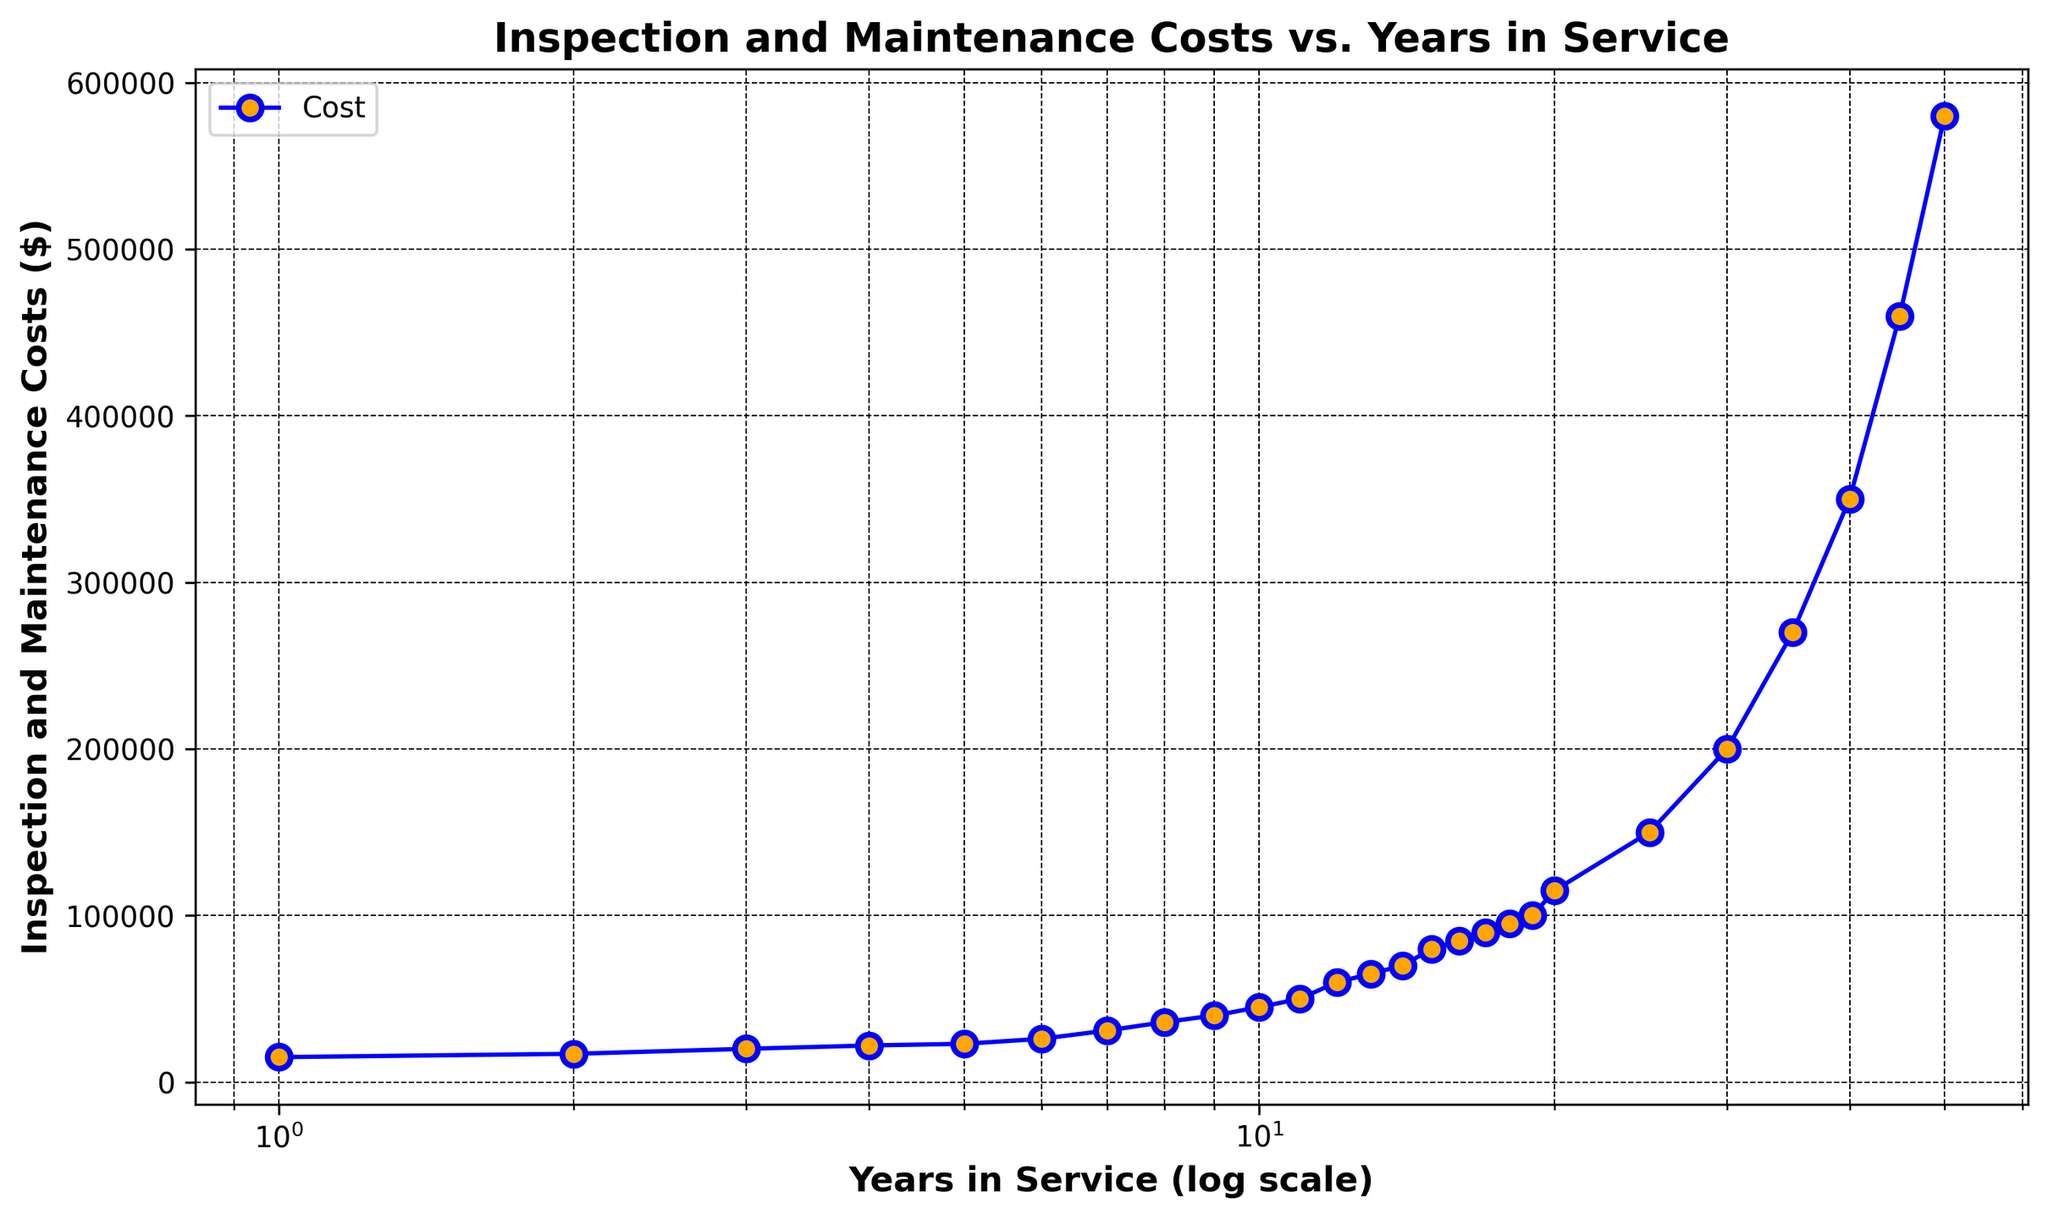What's the cost of inspection and maintenance for oil rigs that have been in service for 10 years? The figure shows the inspection and maintenance costs on the y-axis. At the 10-year mark, the cost is indicated by the corresponding plot point on the graph, which is $45,000.
Answer: $45,000 In which year do inspection and maintenance costs reach $100,000? The y-axis shows the costs, and we look for the corresponding year on the x-axis. The cost of $100,000 is marked at the 19th year on the graph.
Answer: 19 years How much higher are the costs at 20 years compared to 10 years? At 20 years, the cost is $115,000, and at 10 years, it is $45,000. The difference between these amounts is $115,000 - $45,000 = $70,000.
Answer: $70,000 By how much do inspection and maintenance costs increase from 30 to 40 years in service? At 30 years, the cost is $200,000, and at 40 years, it is $350,000. The increase is $350,000 - $200,000 = $150,000.
Answer: $150,000 What is the average cost of inspection and maintenance over the first 5 years? The costs for the first 5 years are $15,000, $17,000, $20,000, $22,000, and $23,000. Adding these amounts gives $15,000 + $17,000 + $20,000 + $22,000 + $23,000 = $97,000. Dividing by 5 gives an average of $97,000 / 5 = $19,400.
Answer: $19,400 At which point does the curve appear to steeply rise on the log scale x-axis? Observing the curve, it starts to rise steeply around the 20-year mark, where costs increase more dramatically.
Answer: Around 20 years What is the trend in inspection and maintenance costs as the years in service increase? The trend shows that costs increase over time. The increase is initially moderate but becomes more rapid, especially noticeable beyond 20 years.
Answer: Costs increase over time, more rapidly after 20 years By what factor do the costs increase from 5 years to 50 years? The cost at 5 years is $23,000, and at 50 years, it is $580,000. The factor increase is $580,000 / $23,000 ≈ 25.22.
Answer: About 25.22 times 